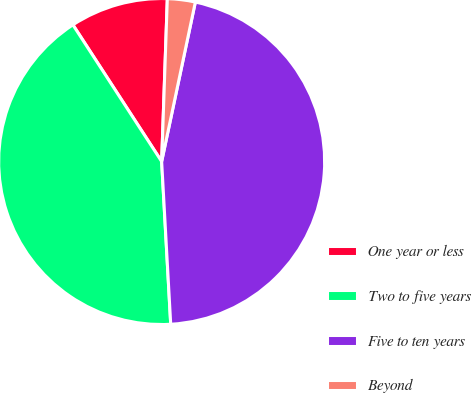Convert chart to OTSL. <chart><loc_0><loc_0><loc_500><loc_500><pie_chart><fcel>One year or less<fcel>Two to five years<fcel>Five to ten years<fcel>Beyond<nl><fcel>9.72%<fcel>41.72%<fcel>45.8%<fcel>2.76%<nl></chart> 